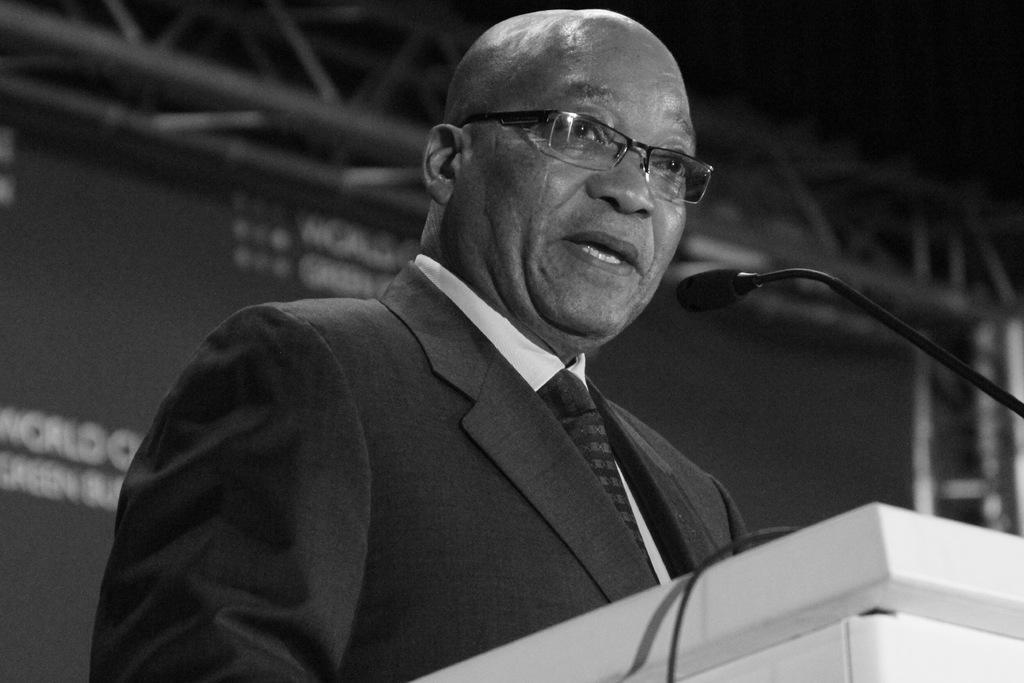Could you give a brief overview of what you see in this image? It is the black and white image in which there is a man standing near the podium. In front of him there is a mic. In the background there is a banner. 